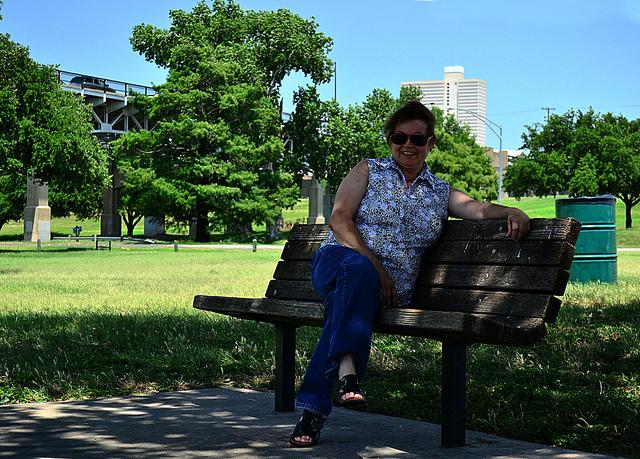What forms the shadow on the woman? Please explain your reasoning. tree. The tree is towering over the woman. 